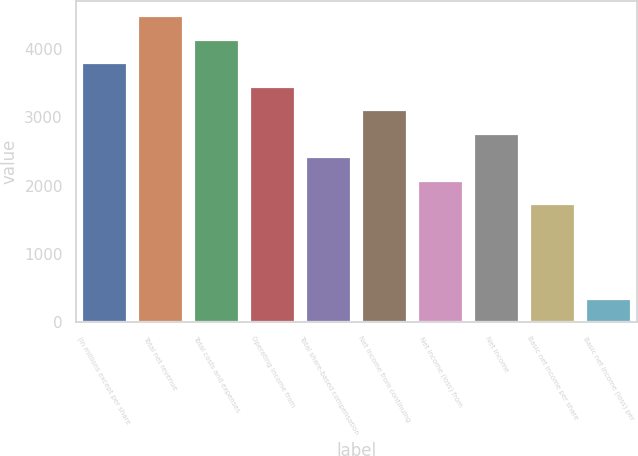Convert chart. <chart><loc_0><loc_0><loc_500><loc_500><bar_chart><fcel>(In millions except per share<fcel>Total net revenue<fcel>Total costs and expenses<fcel>Operating income from<fcel>Total share-based compensation<fcel>Net income from continuing<fcel>Net income (loss) from<fcel>Net income<fcel>Basic net income per share<fcel>Basic net income (loss) per<nl><fcel>3793.85<fcel>4483.61<fcel>4138.73<fcel>3448.97<fcel>2414.33<fcel>3104.09<fcel>2069.45<fcel>2759.21<fcel>1724.57<fcel>345.05<nl></chart> 